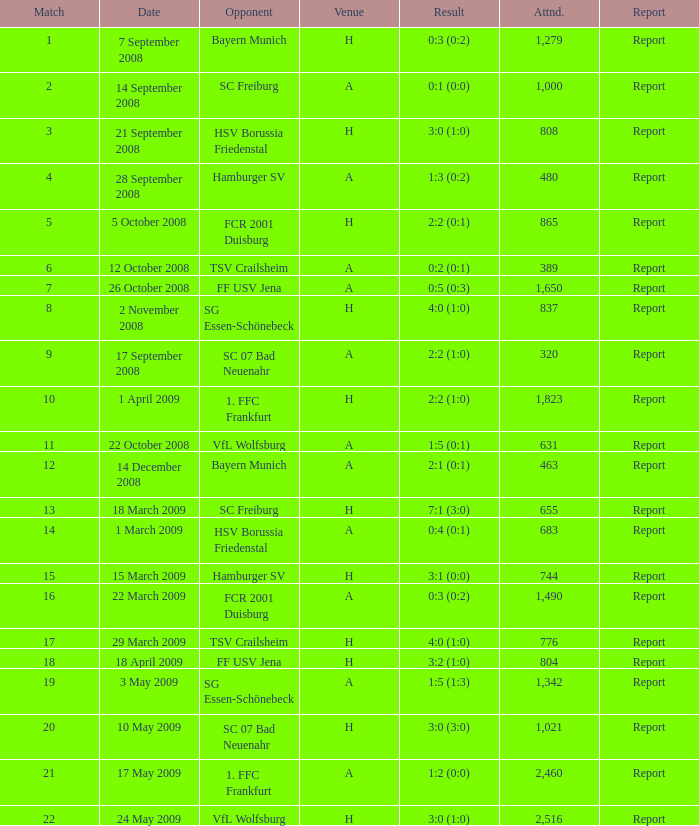What is the fixture number that produced a result of 0:5 (0:3)? 1.0. 